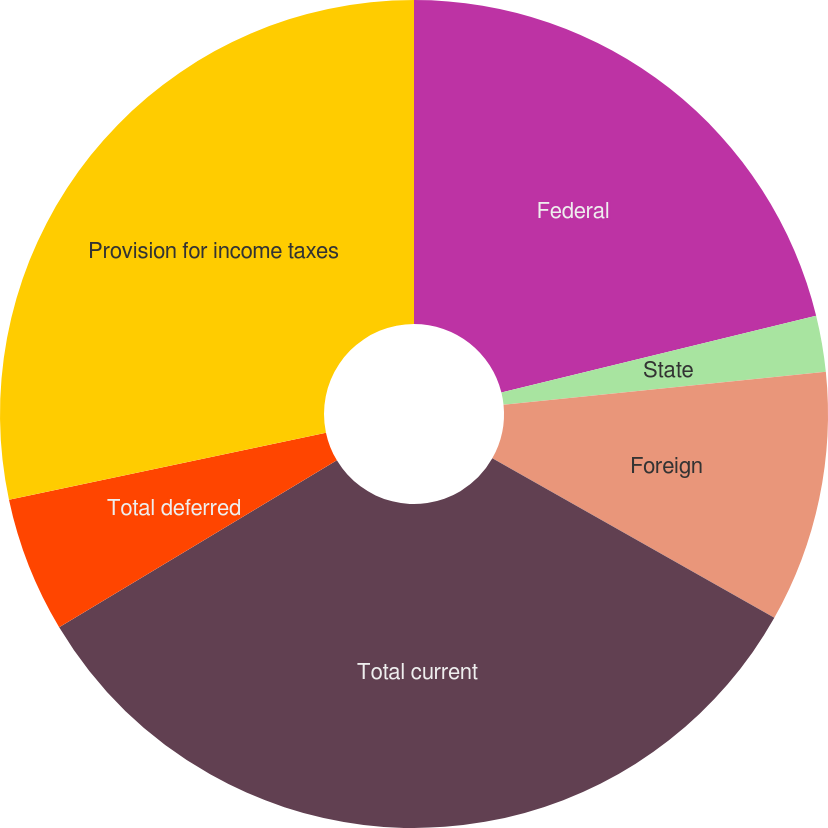Convert chart. <chart><loc_0><loc_0><loc_500><loc_500><pie_chart><fcel>Federal<fcel>State<fcel>Foreign<fcel>Total current<fcel>Total deferred<fcel>Provision for income taxes<nl><fcel>21.18%<fcel>2.19%<fcel>9.82%<fcel>33.19%<fcel>5.29%<fcel>28.32%<nl></chart> 